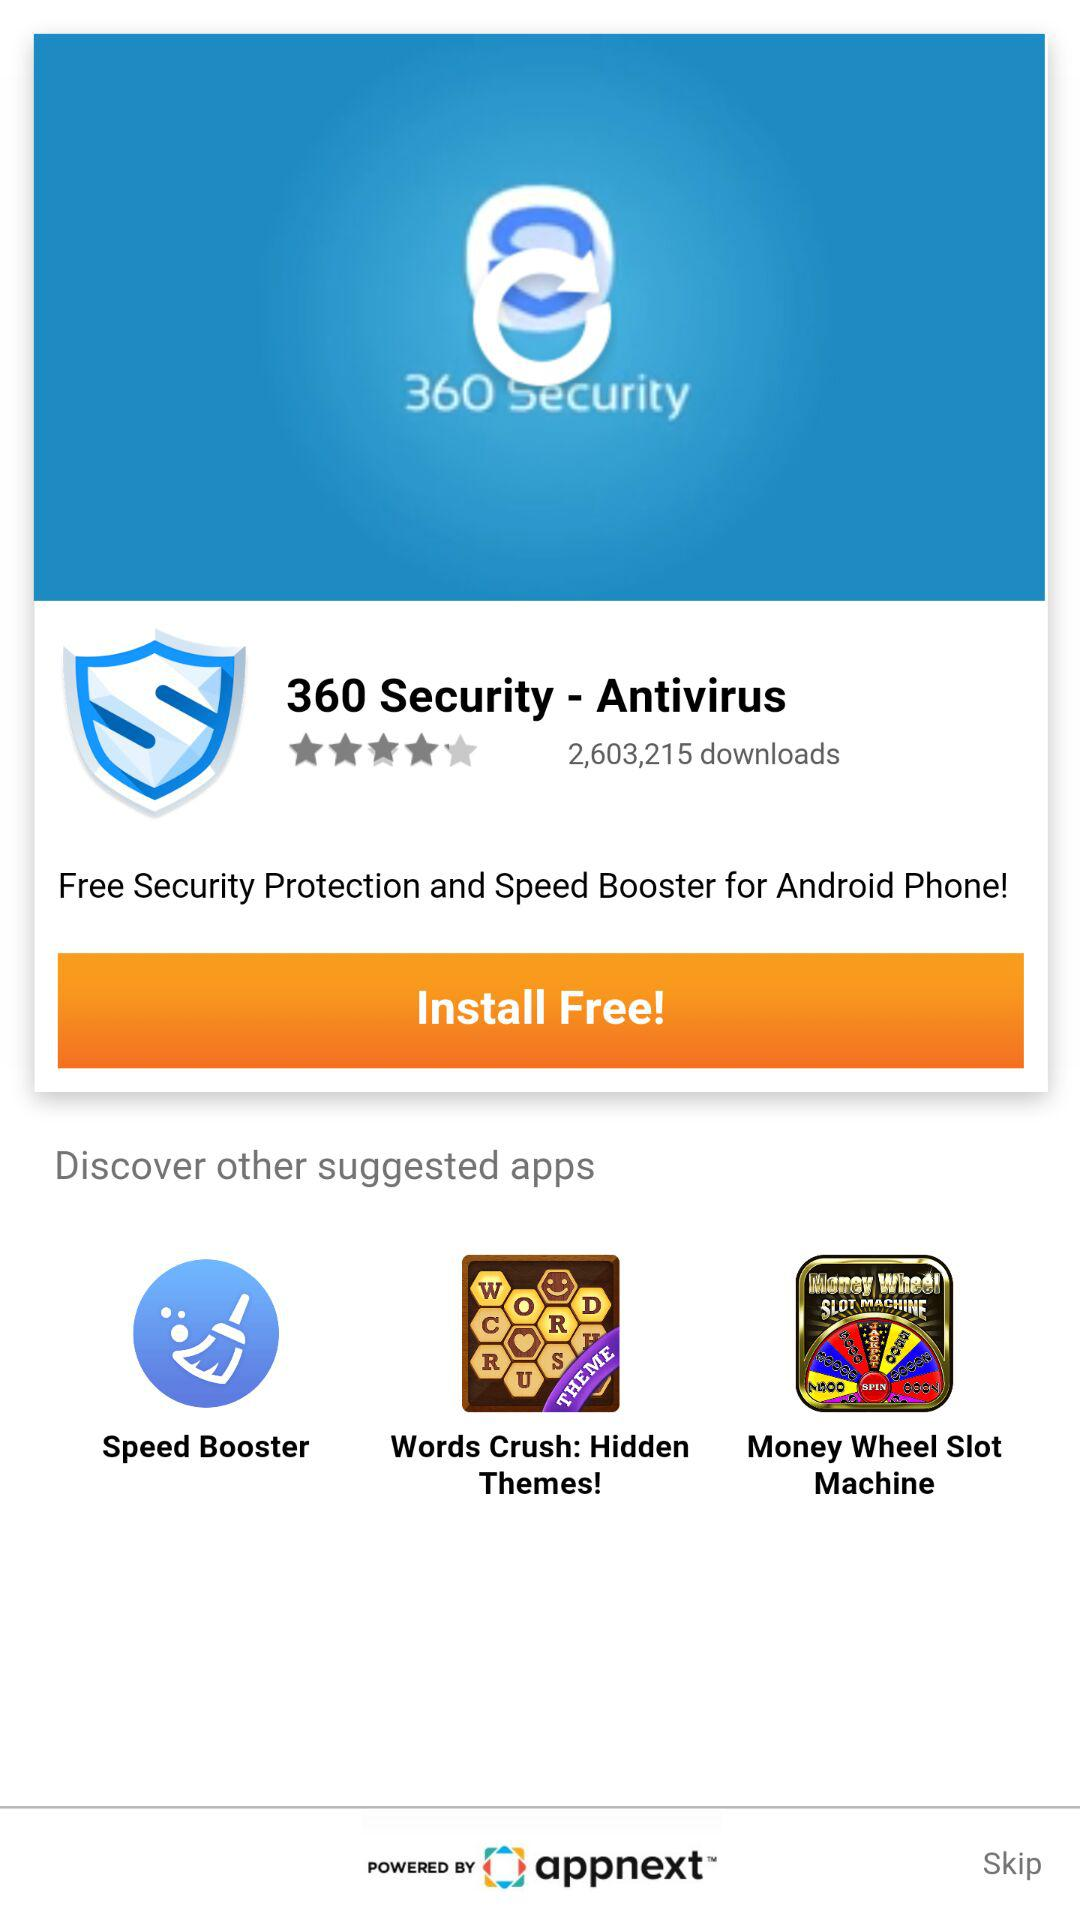How many suggested apps are there?
Answer the question using a single word or phrase. 3 